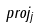Convert formula to latex. <formula><loc_0><loc_0><loc_500><loc_500>p r o j _ { j }</formula> 